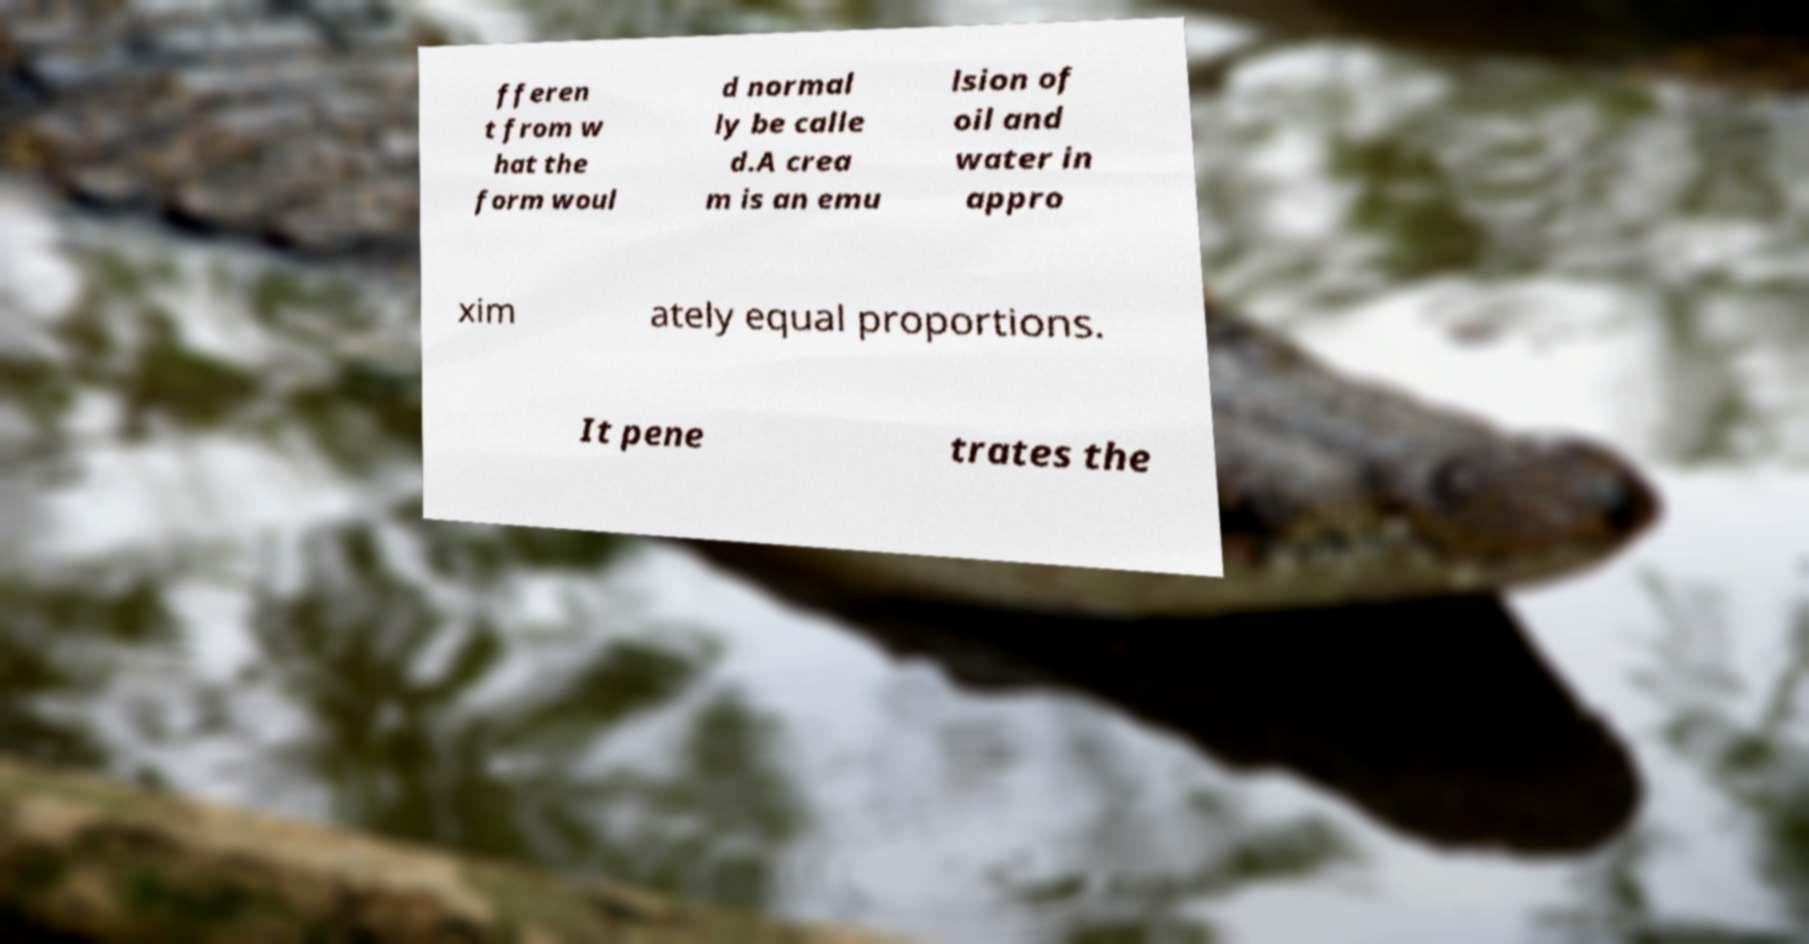Please identify and transcribe the text found in this image. fferen t from w hat the form woul d normal ly be calle d.A crea m is an emu lsion of oil and water in appro xim ately equal proportions. It pene trates the 